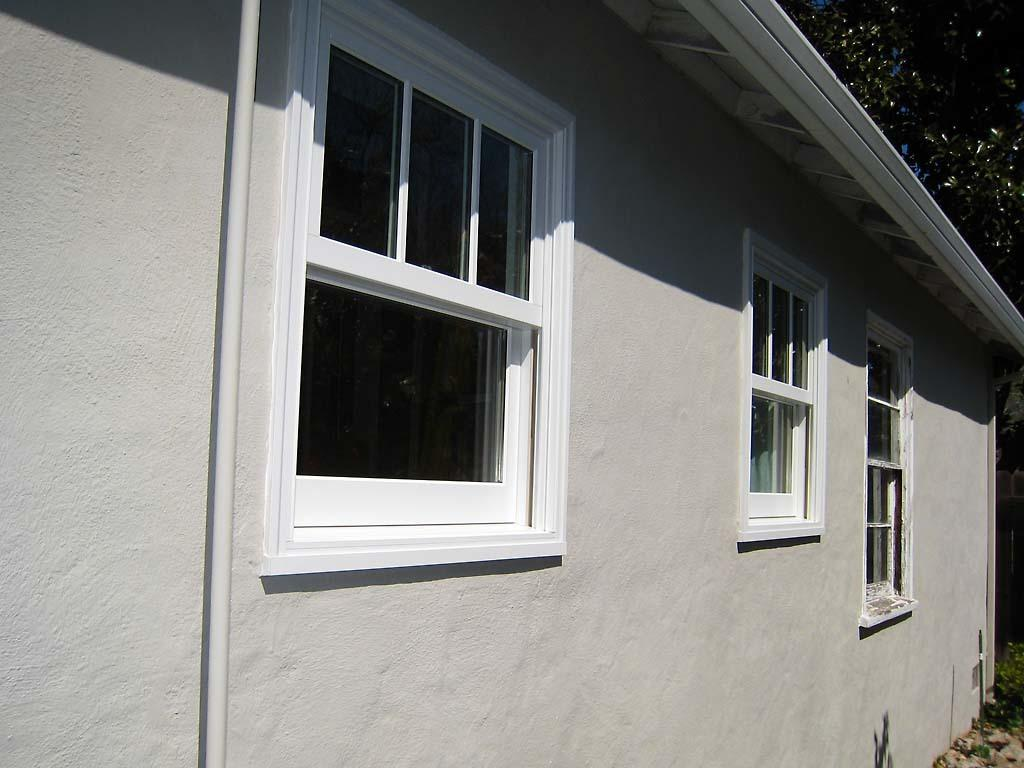What is the color of the wall in the image? The wall in the image is white. What feature is present on the wall? There is a glass window on the wall. What else is attached to the wall? A pipe is attached to the wall. What can be seen in the upper right corner of the image? There is a tree at the right top of the image. What type of clover is growing on the wall in the image? There is no clover present in the image; it features a white wall, a glass window, a pipe, and a tree. 